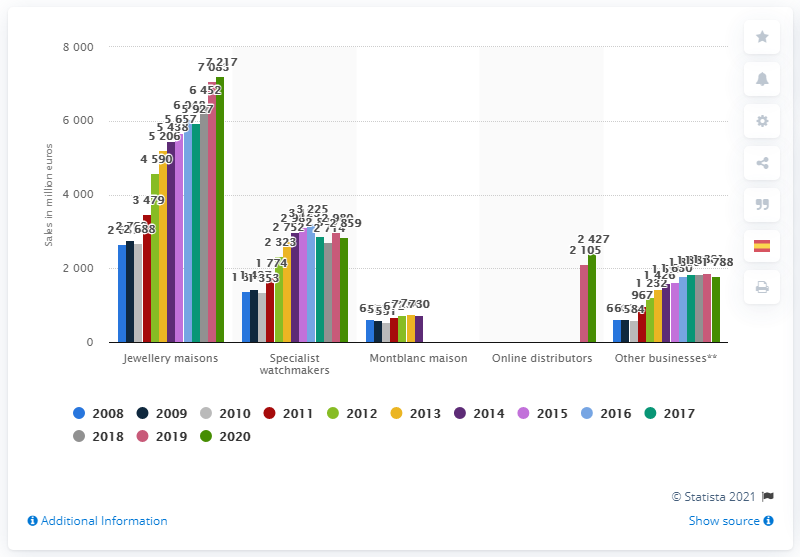Give some essential details in this illustration. The global sales of the Richemont Group's specialist watchmakers segment in FY2020 were 2879. 